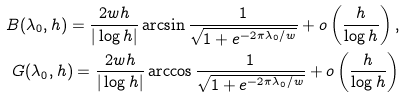<formula> <loc_0><loc_0><loc_500><loc_500>B ( \lambda _ { 0 } , h ) = \frac { 2 w h } { | \log h | } \arcsin \frac { 1 } { \sqrt { 1 + e ^ { - 2 \pi \lambda _ { 0 } / w } } } + o \left ( \frac { h } { \log h } \right ) , \\ G ( \lambda _ { 0 } , h ) = \frac { 2 w h } { | \log h | } \arccos \frac { 1 } { \sqrt { 1 + e ^ { - 2 \pi \lambda _ { 0 } / w } } } + o \left ( \frac { h } { \log h } \right )</formula> 